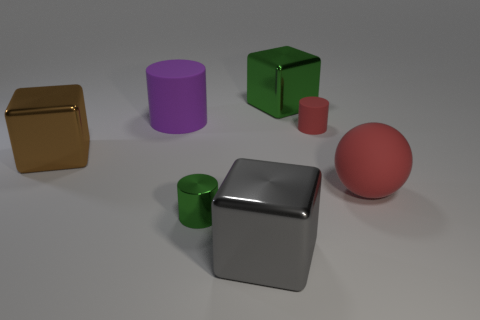What is the size of the green metallic cylinder behind the gray shiny block that is on the right side of the brown metal object?
Make the answer very short. Small. Is the number of large green metallic things that are in front of the red cylinder the same as the number of small red cylinders that are right of the large matte sphere?
Offer a terse response. Yes. The other metal thing that is the same shape as the large purple object is what color?
Offer a very short reply. Green. What number of big cubes have the same color as the shiny cylinder?
Make the answer very short. 1. Is the shape of the big metallic thing behind the big purple cylinder the same as  the large red thing?
Provide a succinct answer. No. What is the shape of the green thing that is right of the tiny thing in front of the shiny block on the left side of the green metallic cylinder?
Your answer should be very brief. Cube. The brown thing has what size?
Provide a succinct answer. Large. What is the color of the tiny thing that is made of the same material as the ball?
Your answer should be compact. Red. What number of red objects are made of the same material as the large gray cube?
Ensure brevity in your answer.  0. Does the large rubber cylinder have the same color as the large metallic thing to the left of the large gray metallic block?
Offer a very short reply. No. 